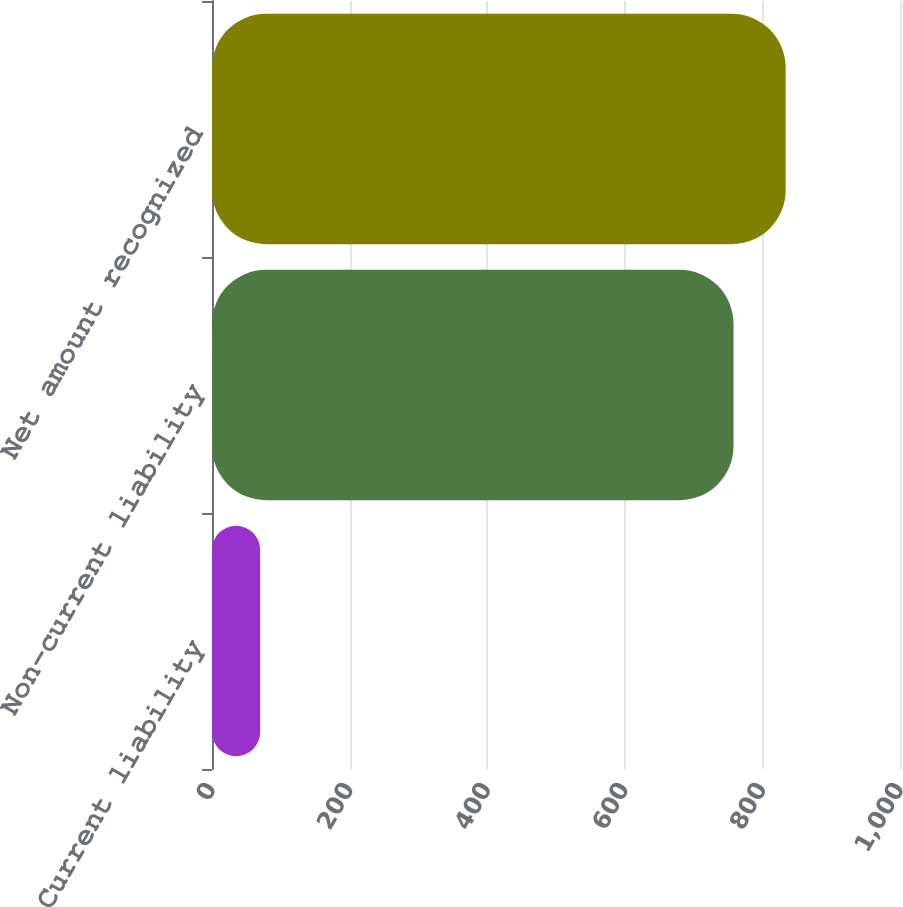<chart> <loc_0><loc_0><loc_500><loc_500><bar_chart><fcel>Current liability<fcel>Non-current liability<fcel>Net amount recognized<nl><fcel>70<fcel>758<fcel>833.8<nl></chart> 